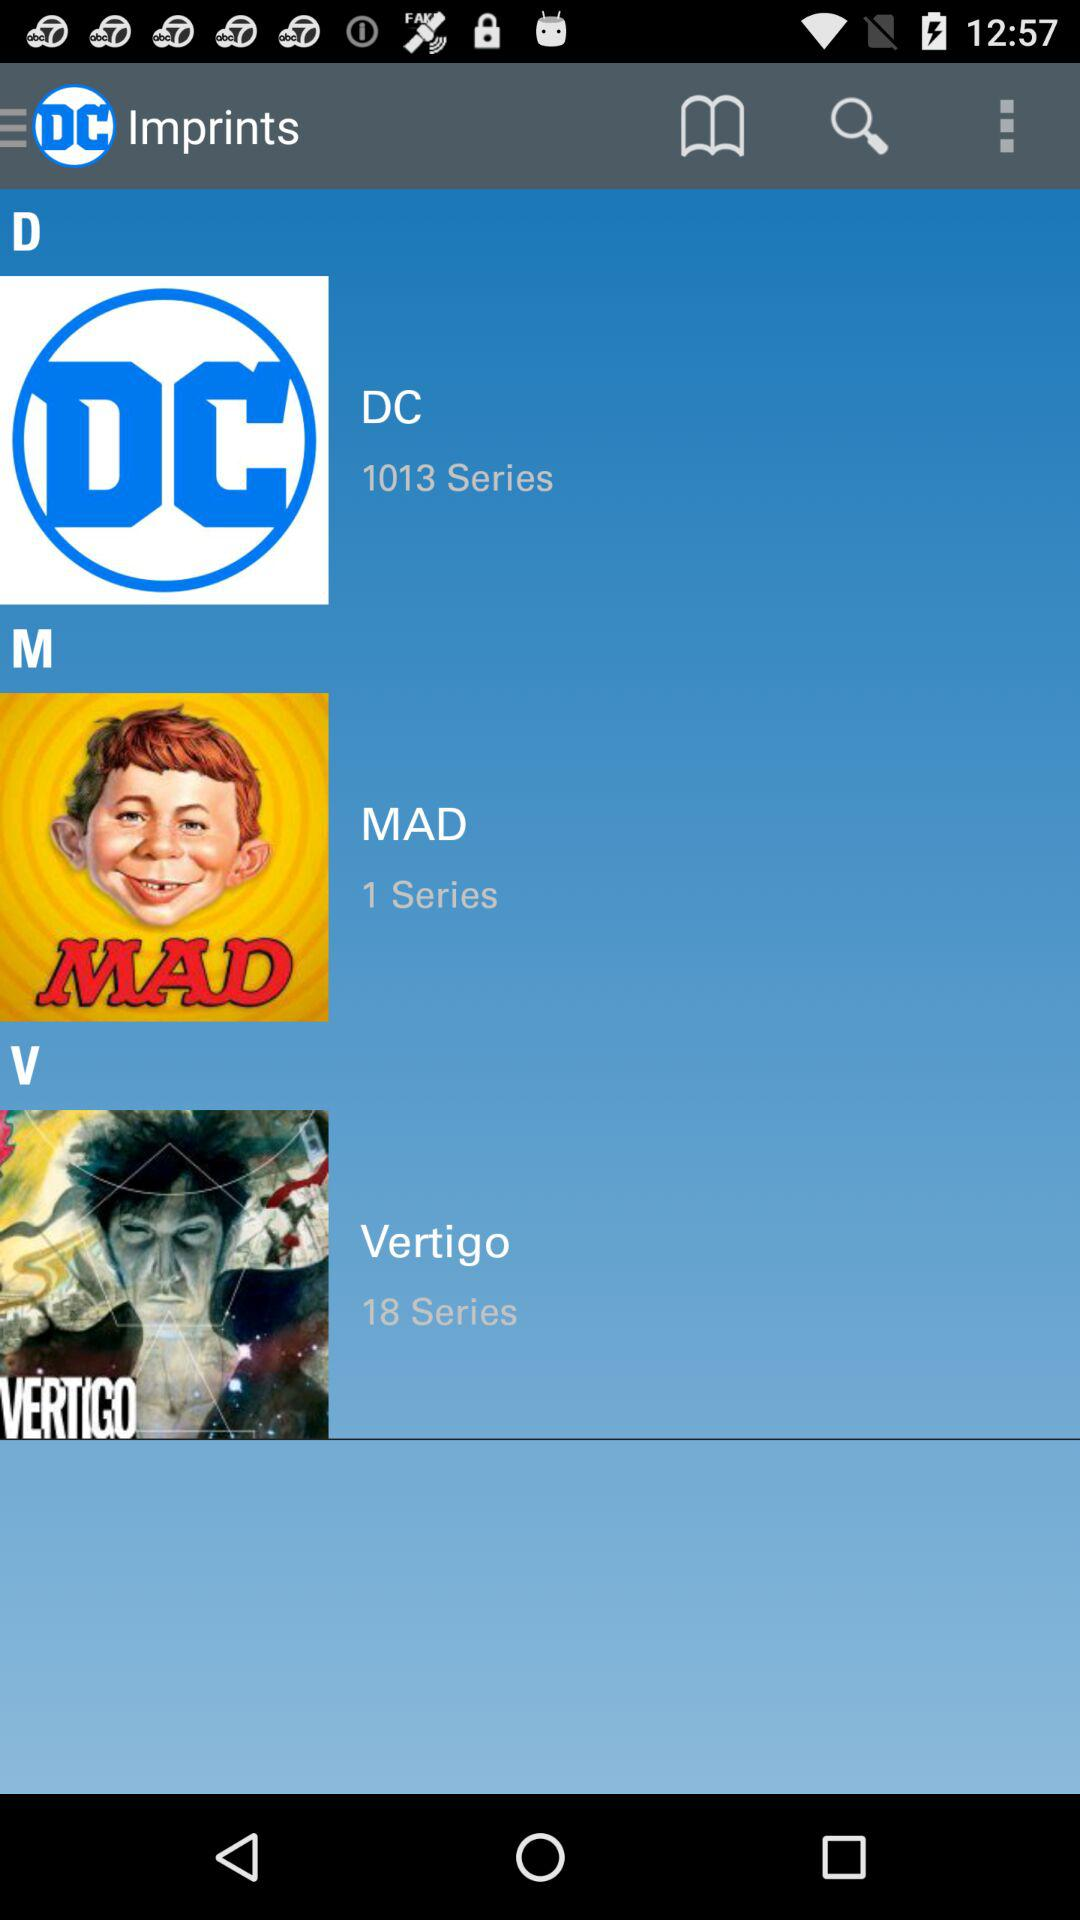What is the number of series in "DC"? The number of series in "DC" is 1013. 